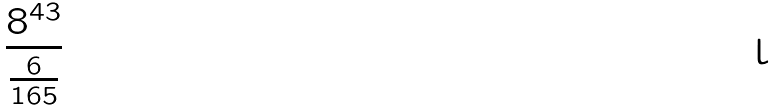<formula> <loc_0><loc_0><loc_500><loc_500>\frac { 8 ^ { 4 3 } } { \frac { 6 } { 1 6 5 } }</formula> 